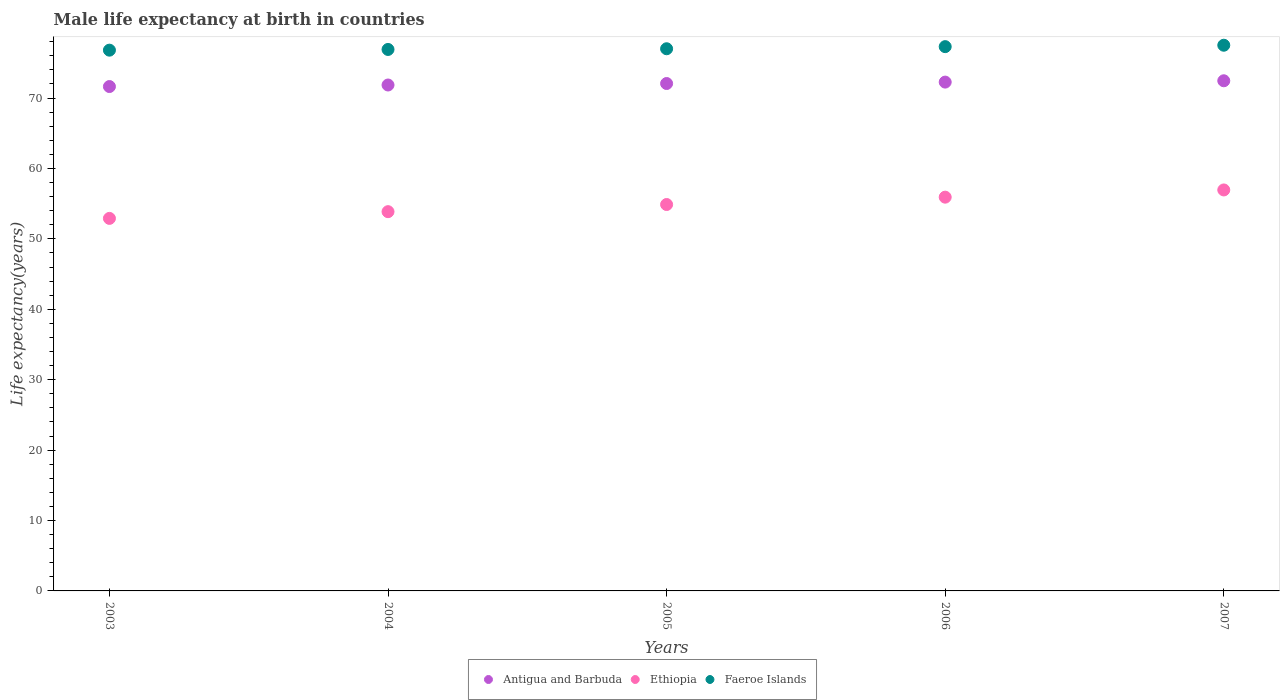How many different coloured dotlines are there?
Give a very brief answer. 3. What is the male life expectancy at birth in Faeroe Islands in 2003?
Your response must be concise. 76.8. Across all years, what is the maximum male life expectancy at birth in Antigua and Barbuda?
Make the answer very short. 72.45. Across all years, what is the minimum male life expectancy at birth in Ethiopia?
Your response must be concise. 52.91. In which year was the male life expectancy at birth in Faeroe Islands maximum?
Provide a succinct answer. 2007. What is the total male life expectancy at birth in Antigua and Barbuda in the graph?
Your answer should be compact. 360.26. What is the difference between the male life expectancy at birth in Ethiopia in 2003 and that in 2007?
Your answer should be very brief. -4.04. What is the difference between the male life expectancy at birth in Faeroe Islands in 2004 and the male life expectancy at birth in Ethiopia in 2007?
Make the answer very short. 19.95. What is the average male life expectancy at birth in Ethiopia per year?
Your answer should be compact. 54.9. In the year 2006, what is the difference between the male life expectancy at birth in Faeroe Islands and male life expectancy at birth in Ethiopia?
Provide a short and direct response. 21.38. In how many years, is the male life expectancy at birth in Ethiopia greater than 16 years?
Offer a very short reply. 5. What is the ratio of the male life expectancy at birth in Antigua and Barbuda in 2003 to that in 2006?
Provide a short and direct response. 0.99. Is the difference between the male life expectancy at birth in Faeroe Islands in 2005 and 2006 greater than the difference between the male life expectancy at birth in Ethiopia in 2005 and 2006?
Provide a succinct answer. Yes. What is the difference between the highest and the second highest male life expectancy at birth in Ethiopia?
Provide a succinct answer. 1.03. What is the difference between the highest and the lowest male life expectancy at birth in Antigua and Barbuda?
Provide a succinct answer. 0.82. In how many years, is the male life expectancy at birth in Faeroe Islands greater than the average male life expectancy at birth in Faeroe Islands taken over all years?
Ensure brevity in your answer.  2. Is the sum of the male life expectancy at birth in Ethiopia in 2003 and 2006 greater than the maximum male life expectancy at birth in Faeroe Islands across all years?
Make the answer very short. Yes. Does the male life expectancy at birth in Ethiopia monotonically increase over the years?
Keep it short and to the point. Yes. Is the male life expectancy at birth in Faeroe Islands strictly greater than the male life expectancy at birth in Ethiopia over the years?
Give a very brief answer. Yes. How many dotlines are there?
Offer a terse response. 3. What is the difference between two consecutive major ticks on the Y-axis?
Ensure brevity in your answer.  10. Does the graph contain any zero values?
Provide a short and direct response. No. Does the graph contain grids?
Give a very brief answer. No. Where does the legend appear in the graph?
Your answer should be compact. Bottom center. How are the legend labels stacked?
Provide a succinct answer. Horizontal. What is the title of the graph?
Your answer should be compact. Male life expectancy at birth in countries. Does "OECD members" appear as one of the legend labels in the graph?
Ensure brevity in your answer.  No. What is the label or title of the X-axis?
Your response must be concise. Years. What is the label or title of the Y-axis?
Ensure brevity in your answer.  Life expectancy(years). What is the Life expectancy(years) of Antigua and Barbuda in 2003?
Give a very brief answer. 71.63. What is the Life expectancy(years) of Ethiopia in 2003?
Your answer should be compact. 52.91. What is the Life expectancy(years) of Faeroe Islands in 2003?
Make the answer very short. 76.8. What is the Life expectancy(years) in Antigua and Barbuda in 2004?
Your answer should be compact. 71.85. What is the Life expectancy(years) of Ethiopia in 2004?
Keep it short and to the point. 53.86. What is the Life expectancy(years) in Faeroe Islands in 2004?
Keep it short and to the point. 76.9. What is the Life expectancy(years) in Antigua and Barbuda in 2005?
Provide a succinct answer. 72.06. What is the Life expectancy(years) of Ethiopia in 2005?
Provide a succinct answer. 54.88. What is the Life expectancy(years) of Antigua and Barbuda in 2006?
Your answer should be very brief. 72.26. What is the Life expectancy(years) in Ethiopia in 2006?
Offer a terse response. 55.92. What is the Life expectancy(years) in Faeroe Islands in 2006?
Your response must be concise. 77.3. What is the Life expectancy(years) in Antigua and Barbuda in 2007?
Make the answer very short. 72.45. What is the Life expectancy(years) of Ethiopia in 2007?
Provide a short and direct response. 56.95. What is the Life expectancy(years) in Faeroe Islands in 2007?
Your answer should be very brief. 77.5. Across all years, what is the maximum Life expectancy(years) of Antigua and Barbuda?
Ensure brevity in your answer.  72.45. Across all years, what is the maximum Life expectancy(years) of Ethiopia?
Your response must be concise. 56.95. Across all years, what is the maximum Life expectancy(years) of Faeroe Islands?
Provide a short and direct response. 77.5. Across all years, what is the minimum Life expectancy(years) of Antigua and Barbuda?
Keep it short and to the point. 71.63. Across all years, what is the minimum Life expectancy(years) in Ethiopia?
Offer a terse response. 52.91. Across all years, what is the minimum Life expectancy(years) in Faeroe Islands?
Keep it short and to the point. 76.8. What is the total Life expectancy(years) of Antigua and Barbuda in the graph?
Give a very brief answer. 360.26. What is the total Life expectancy(years) in Ethiopia in the graph?
Your answer should be compact. 274.52. What is the total Life expectancy(years) of Faeroe Islands in the graph?
Your response must be concise. 385.5. What is the difference between the Life expectancy(years) in Antigua and Barbuda in 2003 and that in 2004?
Your answer should be very brief. -0.22. What is the difference between the Life expectancy(years) in Ethiopia in 2003 and that in 2004?
Your answer should be compact. -0.95. What is the difference between the Life expectancy(years) of Antigua and Barbuda in 2003 and that in 2005?
Your response must be concise. -0.43. What is the difference between the Life expectancy(years) in Ethiopia in 2003 and that in 2005?
Provide a succinct answer. -1.97. What is the difference between the Life expectancy(years) in Faeroe Islands in 2003 and that in 2005?
Provide a succinct answer. -0.2. What is the difference between the Life expectancy(years) in Antigua and Barbuda in 2003 and that in 2006?
Make the answer very short. -0.63. What is the difference between the Life expectancy(years) in Ethiopia in 2003 and that in 2006?
Keep it short and to the point. -3.01. What is the difference between the Life expectancy(years) in Faeroe Islands in 2003 and that in 2006?
Your answer should be very brief. -0.5. What is the difference between the Life expectancy(years) of Antigua and Barbuda in 2003 and that in 2007?
Offer a very short reply. -0.82. What is the difference between the Life expectancy(years) in Ethiopia in 2003 and that in 2007?
Offer a terse response. -4.04. What is the difference between the Life expectancy(years) of Faeroe Islands in 2003 and that in 2007?
Your response must be concise. -0.7. What is the difference between the Life expectancy(years) of Antigua and Barbuda in 2004 and that in 2005?
Offer a very short reply. -0.21. What is the difference between the Life expectancy(years) of Ethiopia in 2004 and that in 2005?
Your answer should be very brief. -1.02. What is the difference between the Life expectancy(years) in Antigua and Barbuda in 2004 and that in 2006?
Offer a very short reply. -0.41. What is the difference between the Life expectancy(years) of Ethiopia in 2004 and that in 2006?
Provide a succinct answer. -2.06. What is the difference between the Life expectancy(years) of Faeroe Islands in 2004 and that in 2006?
Your answer should be compact. -0.4. What is the difference between the Life expectancy(years) in Antigua and Barbuda in 2004 and that in 2007?
Give a very brief answer. -0.6. What is the difference between the Life expectancy(years) in Ethiopia in 2004 and that in 2007?
Keep it short and to the point. -3.08. What is the difference between the Life expectancy(years) of Antigua and Barbuda in 2005 and that in 2006?
Your answer should be compact. -0.2. What is the difference between the Life expectancy(years) in Ethiopia in 2005 and that in 2006?
Keep it short and to the point. -1.04. What is the difference between the Life expectancy(years) in Faeroe Islands in 2005 and that in 2006?
Your answer should be compact. -0.3. What is the difference between the Life expectancy(years) of Antigua and Barbuda in 2005 and that in 2007?
Offer a very short reply. -0.39. What is the difference between the Life expectancy(years) of Ethiopia in 2005 and that in 2007?
Offer a very short reply. -2.07. What is the difference between the Life expectancy(years) in Faeroe Islands in 2005 and that in 2007?
Your answer should be very brief. -0.5. What is the difference between the Life expectancy(years) of Antigua and Barbuda in 2006 and that in 2007?
Keep it short and to the point. -0.19. What is the difference between the Life expectancy(years) of Ethiopia in 2006 and that in 2007?
Your response must be concise. -1.03. What is the difference between the Life expectancy(years) in Antigua and Barbuda in 2003 and the Life expectancy(years) in Ethiopia in 2004?
Make the answer very short. 17.77. What is the difference between the Life expectancy(years) of Antigua and Barbuda in 2003 and the Life expectancy(years) of Faeroe Islands in 2004?
Give a very brief answer. -5.27. What is the difference between the Life expectancy(years) in Ethiopia in 2003 and the Life expectancy(years) in Faeroe Islands in 2004?
Offer a very short reply. -23.99. What is the difference between the Life expectancy(years) in Antigua and Barbuda in 2003 and the Life expectancy(years) in Ethiopia in 2005?
Your response must be concise. 16.75. What is the difference between the Life expectancy(years) of Antigua and Barbuda in 2003 and the Life expectancy(years) of Faeroe Islands in 2005?
Provide a short and direct response. -5.37. What is the difference between the Life expectancy(years) in Ethiopia in 2003 and the Life expectancy(years) in Faeroe Islands in 2005?
Your response must be concise. -24.09. What is the difference between the Life expectancy(years) in Antigua and Barbuda in 2003 and the Life expectancy(years) in Ethiopia in 2006?
Offer a terse response. 15.71. What is the difference between the Life expectancy(years) in Antigua and Barbuda in 2003 and the Life expectancy(years) in Faeroe Islands in 2006?
Ensure brevity in your answer.  -5.67. What is the difference between the Life expectancy(years) in Ethiopia in 2003 and the Life expectancy(years) in Faeroe Islands in 2006?
Your answer should be very brief. -24.39. What is the difference between the Life expectancy(years) in Antigua and Barbuda in 2003 and the Life expectancy(years) in Ethiopia in 2007?
Provide a succinct answer. 14.69. What is the difference between the Life expectancy(years) in Antigua and Barbuda in 2003 and the Life expectancy(years) in Faeroe Islands in 2007?
Provide a succinct answer. -5.87. What is the difference between the Life expectancy(years) of Ethiopia in 2003 and the Life expectancy(years) of Faeroe Islands in 2007?
Keep it short and to the point. -24.59. What is the difference between the Life expectancy(years) in Antigua and Barbuda in 2004 and the Life expectancy(years) in Ethiopia in 2005?
Provide a short and direct response. 16.97. What is the difference between the Life expectancy(years) in Antigua and Barbuda in 2004 and the Life expectancy(years) in Faeroe Islands in 2005?
Give a very brief answer. -5.15. What is the difference between the Life expectancy(years) of Ethiopia in 2004 and the Life expectancy(years) of Faeroe Islands in 2005?
Give a very brief answer. -23.14. What is the difference between the Life expectancy(years) in Antigua and Barbuda in 2004 and the Life expectancy(years) in Ethiopia in 2006?
Provide a short and direct response. 15.93. What is the difference between the Life expectancy(years) of Antigua and Barbuda in 2004 and the Life expectancy(years) of Faeroe Islands in 2006?
Offer a very short reply. -5.45. What is the difference between the Life expectancy(years) in Ethiopia in 2004 and the Life expectancy(years) in Faeroe Islands in 2006?
Ensure brevity in your answer.  -23.44. What is the difference between the Life expectancy(years) of Antigua and Barbuda in 2004 and the Life expectancy(years) of Ethiopia in 2007?
Give a very brief answer. 14.9. What is the difference between the Life expectancy(years) in Antigua and Barbuda in 2004 and the Life expectancy(years) in Faeroe Islands in 2007?
Provide a succinct answer. -5.65. What is the difference between the Life expectancy(years) of Ethiopia in 2004 and the Life expectancy(years) of Faeroe Islands in 2007?
Give a very brief answer. -23.64. What is the difference between the Life expectancy(years) of Antigua and Barbuda in 2005 and the Life expectancy(years) of Ethiopia in 2006?
Provide a short and direct response. 16.14. What is the difference between the Life expectancy(years) in Antigua and Barbuda in 2005 and the Life expectancy(years) in Faeroe Islands in 2006?
Give a very brief answer. -5.24. What is the difference between the Life expectancy(years) in Ethiopia in 2005 and the Life expectancy(years) in Faeroe Islands in 2006?
Your answer should be compact. -22.42. What is the difference between the Life expectancy(years) in Antigua and Barbuda in 2005 and the Life expectancy(years) in Ethiopia in 2007?
Offer a terse response. 15.12. What is the difference between the Life expectancy(years) in Antigua and Barbuda in 2005 and the Life expectancy(years) in Faeroe Islands in 2007?
Give a very brief answer. -5.44. What is the difference between the Life expectancy(years) of Ethiopia in 2005 and the Life expectancy(years) of Faeroe Islands in 2007?
Your answer should be very brief. -22.62. What is the difference between the Life expectancy(years) in Antigua and Barbuda in 2006 and the Life expectancy(years) in Ethiopia in 2007?
Your answer should be very brief. 15.32. What is the difference between the Life expectancy(years) of Antigua and Barbuda in 2006 and the Life expectancy(years) of Faeroe Islands in 2007?
Your answer should be very brief. -5.24. What is the difference between the Life expectancy(years) of Ethiopia in 2006 and the Life expectancy(years) of Faeroe Islands in 2007?
Give a very brief answer. -21.58. What is the average Life expectancy(years) of Antigua and Barbuda per year?
Offer a very short reply. 72.05. What is the average Life expectancy(years) of Ethiopia per year?
Your answer should be compact. 54.9. What is the average Life expectancy(years) in Faeroe Islands per year?
Your answer should be compact. 77.1. In the year 2003, what is the difference between the Life expectancy(years) in Antigua and Barbuda and Life expectancy(years) in Ethiopia?
Make the answer very short. 18.73. In the year 2003, what is the difference between the Life expectancy(years) of Antigua and Barbuda and Life expectancy(years) of Faeroe Islands?
Keep it short and to the point. -5.17. In the year 2003, what is the difference between the Life expectancy(years) in Ethiopia and Life expectancy(years) in Faeroe Islands?
Offer a terse response. -23.89. In the year 2004, what is the difference between the Life expectancy(years) in Antigua and Barbuda and Life expectancy(years) in Ethiopia?
Provide a succinct answer. 17.99. In the year 2004, what is the difference between the Life expectancy(years) of Antigua and Barbuda and Life expectancy(years) of Faeroe Islands?
Offer a very short reply. -5.05. In the year 2004, what is the difference between the Life expectancy(years) of Ethiopia and Life expectancy(years) of Faeroe Islands?
Offer a very short reply. -23.04. In the year 2005, what is the difference between the Life expectancy(years) of Antigua and Barbuda and Life expectancy(years) of Ethiopia?
Your response must be concise. 17.18. In the year 2005, what is the difference between the Life expectancy(years) of Antigua and Barbuda and Life expectancy(years) of Faeroe Islands?
Keep it short and to the point. -4.94. In the year 2005, what is the difference between the Life expectancy(years) in Ethiopia and Life expectancy(years) in Faeroe Islands?
Your response must be concise. -22.12. In the year 2006, what is the difference between the Life expectancy(years) in Antigua and Barbuda and Life expectancy(years) in Ethiopia?
Ensure brevity in your answer.  16.34. In the year 2006, what is the difference between the Life expectancy(years) in Antigua and Barbuda and Life expectancy(years) in Faeroe Islands?
Offer a very short reply. -5.04. In the year 2006, what is the difference between the Life expectancy(years) in Ethiopia and Life expectancy(years) in Faeroe Islands?
Your answer should be compact. -21.38. In the year 2007, what is the difference between the Life expectancy(years) in Antigua and Barbuda and Life expectancy(years) in Ethiopia?
Your answer should be compact. 15.5. In the year 2007, what is the difference between the Life expectancy(years) of Antigua and Barbuda and Life expectancy(years) of Faeroe Islands?
Your answer should be very brief. -5.05. In the year 2007, what is the difference between the Life expectancy(years) in Ethiopia and Life expectancy(years) in Faeroe Islands?
Your response must be concise. -20.55. What is the ratio of the Life expectancy(years) of Ethiopia in 2003 to that in 2004?
Your answer should be very brief. 0.98. What is the ratio of the Life expectancy(years) in Faeroe Islands in 2003 to that in 2004?
Provide a succinct answer. 1. What is the ratio of the Life expectancy(years) of Ethiopia in 2003 to that in 2005?
Offer a terse response. 0.96. What is the ratio of the Life expectancy(years) in Faeroe Islands in 2003 to that in 2005?
Give a very brief answer. 1. What is the ratio of the Life expectancy(years) of Antigua and Barbuda in 2003 to that in 2006?
Make the answer very short. 0.99. What is the ratio of the Life expectancy(years) of Ethiopia in 2003 to that in 2006?
Make the answer very short. 0.95. What is the ratio of the Life expectancy(years) in Antigua and Barbuda in 2003 to that in 2007?
Provide a succinct answer. 0.99. What is the ratio of the Life expectancy(years) of Ethiopia in 2003 to that in 2007?
Your response must be concise. 0.93. What is the ratio of the Life expectancy(years) in Faeroe Islands in 2003 to that in 2007?
Ensure brevity in your answer.  0.99. What is the ratio of the Life expectancy(years) in Ethiopia in 2004 to that in 2005?
Keep it short and to the point. 0.98. What is the ratio of the Life expectancy(years) in Antigua and Barbuda in 2004 to that in 2006?
Offer a very short reply. 0.99. What is the ratio of the Life expectancy(years) in Ethiopia in 2004 to that in 2006?
Make the answer very short. 0.96. What is the ratio of the Life expectancy(years) of Ethiopia in 2004 to that in 2007?
Ensure brevity in your answer.  0.95. What is the ratio of the Life expectancy(years) of Faeroe Islands in 2004 to that in 2007?
Make the answer very short. 0.99. What is the ratio of the Life expectancy(years) in Antigua and Barbuda in 2005 to that in 2006?
Your answer should be compact. 1. What is the ratio of the Life expectancy(years) of Ethiopia in 2005 to that in 2006?
Give a very brief answer. 0.98. What is the ratio of the Life expectancy(years) in Faeroe Islands in 2005 to that in 2006?
Make the answer very short. 1. What is the ratio of the Life expectancy(years) of Ethiopia in 2005 to that in 2007?
Provide a short and direct response. 0.96. What is the ratio of the Life expectancy(years) in Faeroe Islands in 2005 to that in 2007?
Your answer should be very brief. 0.99. What is the difference between the highest and the second highest Life expectancy(years) in Antigua and Barbuda?
Keep it short and to the point. 0.19. What is the difference between the highest and the lowest Life expectancy(years) in Antigua and Barbuda?
Offer a very short reply. 0.82. What is the difference between the highest and the lowest Life expectancy(years) in Ethiopia?
Keep it short and to the point. 4.04. 